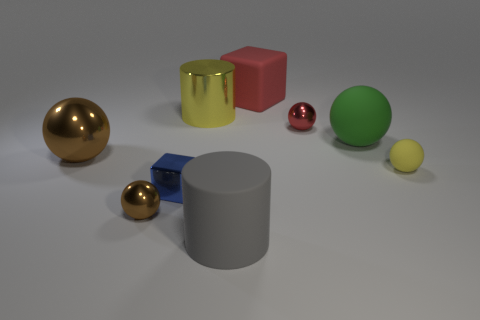Subtract all small spheres. How many spheres are left? 2 Add 1 red things. How many objects exist? 10 Subtract all green balls. How many balls are left? 4 Subtract all cubes. How many objects are left? 7 Subtract all green balls. Subtract all green cubes. How many balls are left? 4 Add 1 balls. How many balls exist? 6 Subtract 1 blue cubes. How many objects are left? 8 Subtract all green blocks. Subtract all large rubber objects. How many objects are left? 6 Add 4 green matte things. How many green matte things are left? 5 